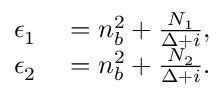Convert formula to latex. <formula><loc_0><loc_0><loc_500><loc_500>\begin{array} { r l } { \epsilon _ { 1 } } & = n _ { b } ^ { 2 } + \frac { N _ { 1 } } { \Delta + i } , } \\ { \epsilon _ { 2 } } & = n _ { b } ^ { 2 } + \frac { N _ { 2 } } { \Delta + i } . } \end{array}</formula> 